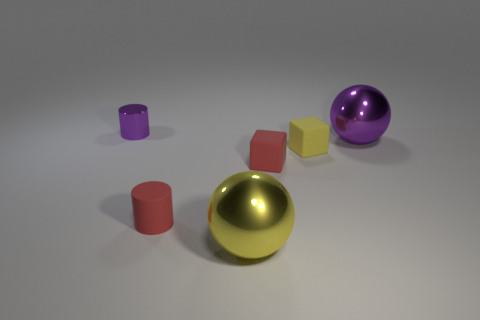Add 1 small shiny objects. How many objects exist? 7 Subtract 0 gray spheres. How many objects are left? 6 Subtract all balls. How many objects are left? 4 Subtract all cyan balls. Subtract all purple cylinders. How many balls are left? 2 Subtract all tiny yellow rubber things. Subtract all tiny objects. How many objects are left? 1 Add 3 large purple metallic balls. How many large purple metallic balls are left? 4 Add 6 spheres. How many spheres exist? 8 